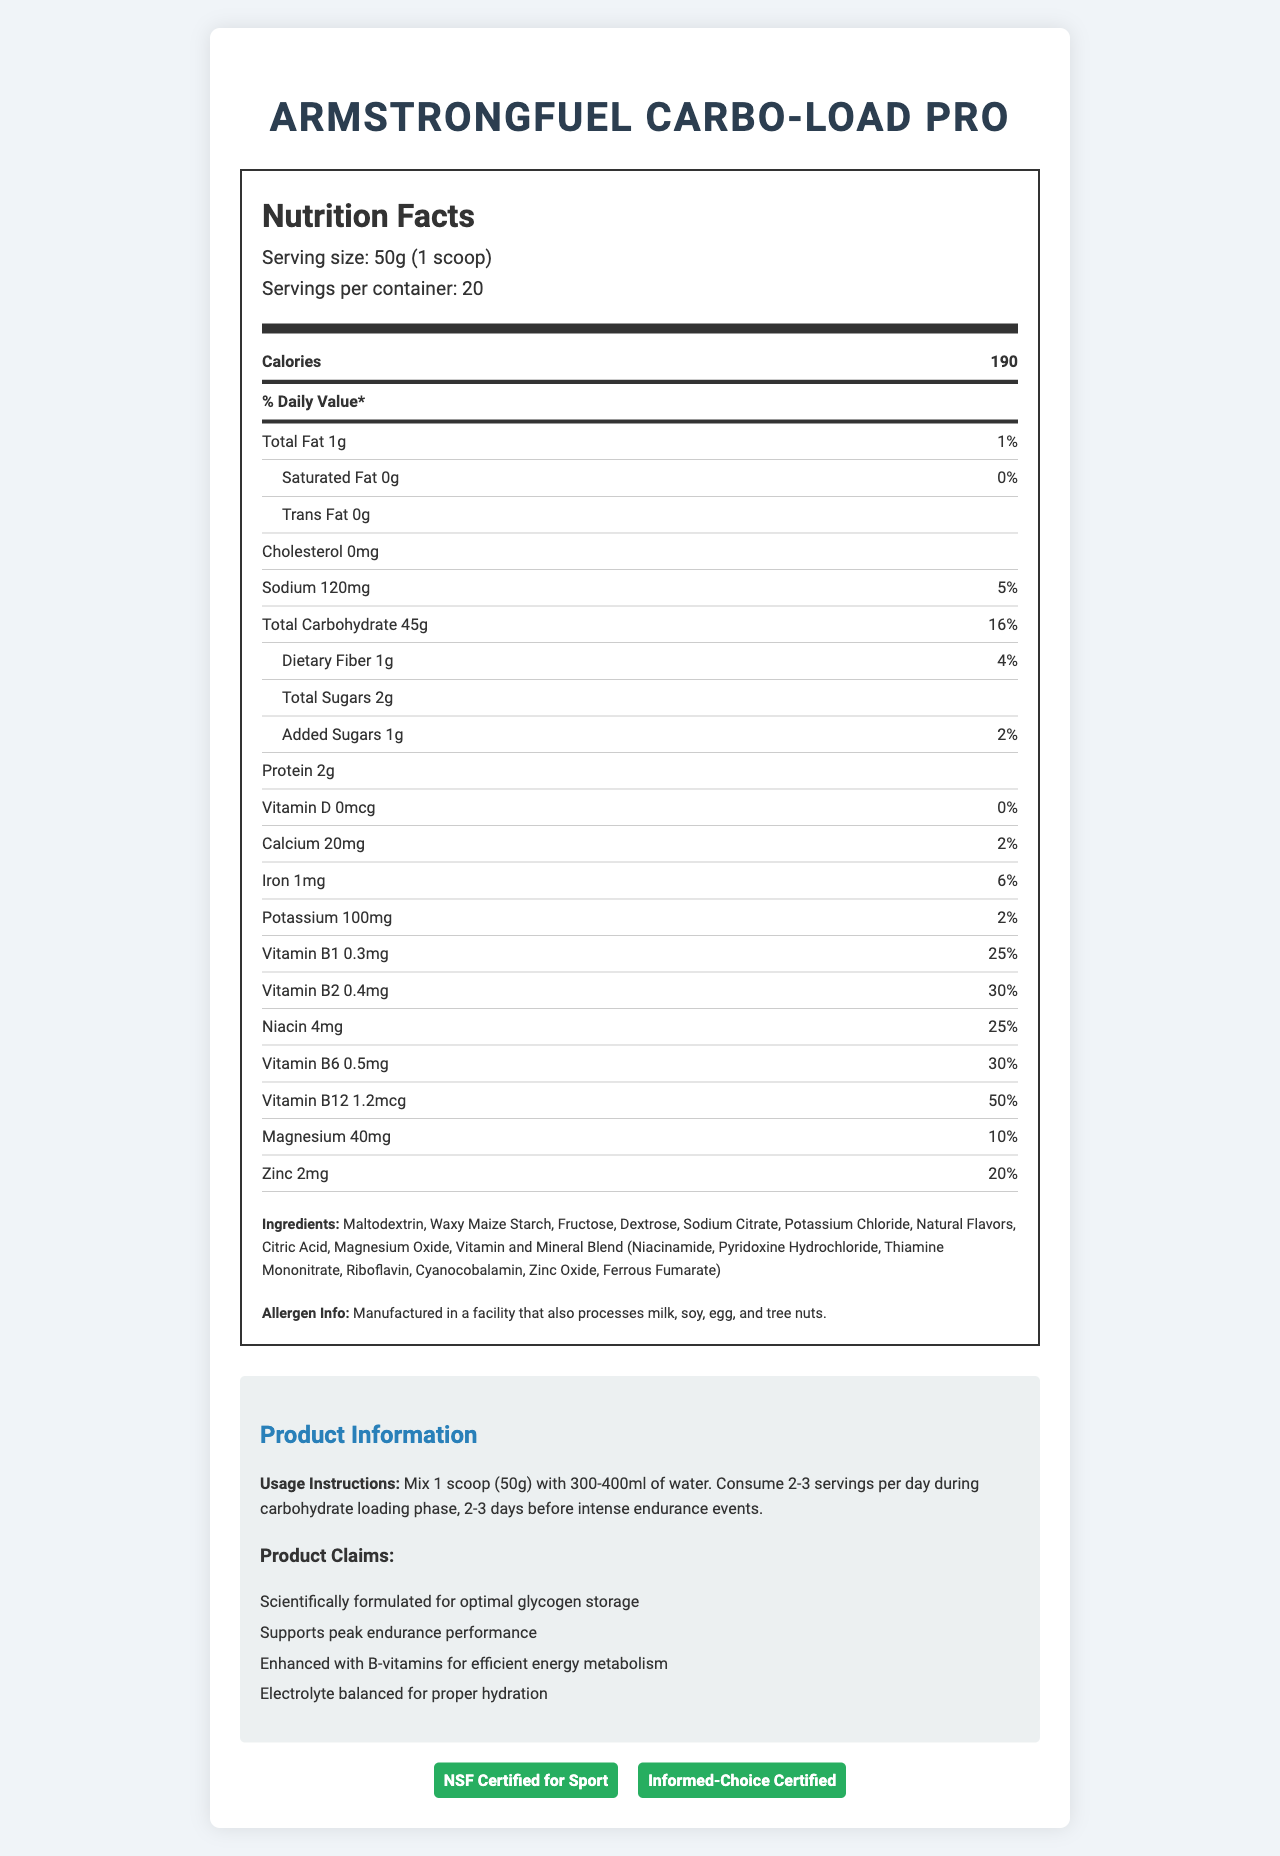what is the serving size for ArmstrongFuel Carbo-Load Pro? The document clearly lists the serving size under the nutrition facts.
Answer: 50g (1 scoop) how many servings are there per container of ArmstrongFuel Carbo-Load Pro? The servings per container information is listed right below the serving size.
Answer: 20 how many calories are there in one serving? The number of calories per serving is listed prominently under the nutrition facts.
Answer: 190 what is the total carbohydrate content per serving? The total carbohydrate content per serving is listed under the nutrition facts with an amount of 45g and a daily value of 16%.
Answer: 45g what are the ingredients listed for ArmstrongFuel Carbo-Load Pro? All the ingredients are listed at the bottom of the nutrition facts section.
Answer: Maltodextrin, Waxy Maize Starch, Fructose, Dextrose, Sodium Citrate, Potassium Chloride, Natural Flavors, Citric Acid, Magnesium Oxide, Vitamin and Mineral Blend (Niacinamide, Pyridoxine Hydrochloride, Thiamine Mononitrate, Riboflavin, Cyanocobalamin, Zinc Oxide, Ferrous Fumarate) How much sodium is in one serving? Sodium is listed in the nutrients section with an amount of 120mg and a daily value of 5%.
Answer: 120mg which vitamins and minerals are provided by this product? A. Vitamin A, Vitamin C B. Vitamin D, Calcium C. Vitamin B1, Vitamin B2, Niacin, Vitamin B6, Vitamin B12, Magnesium, Zinc The document lists Vitamin B1, Vitamin B2, Niacin, Vitamin B6, Vitamin B12, Magnesium, and Zinc with their respective amounts and daily values.
Answer: C what is the daily value percentage for Vitamin B12? A. 25% B. 30% C. 50% D. 100% The daily value percentage for Vitamin B12 is listed as 50%.
Answer: C Is this product certified for sports use? The document mentions that the product is "NSF Certified for Sport" and "Informed-Choice Certified".
Answer: Yes summarize the document's main information. The document intends to inform users about the nutritional content, usage guidelines, and safety certifications of the ArmstrongFuel Carbo-Load Pro supplement.
Answer: The document provides detailed nutrition facts for ArmstrongFuel Carbo-Load Pro, including serving size, calories, macronutrients, vitamins, and minerals. It outlines the ingredients, usage instructions, product claims, allergen information, and certifications. What is the manufacturing facility's allergen information? The allergen information specifies that the product is manufactured in a facility that also processes other common allergens like milk, soy, egg, and tree nuts.
Answer: Manufactured in a facility that also processes milk, soy, egg, and tree nuts. Can this product be used during carbohydrate depletion phases? The document provides usage instructions for carbohydrate loading phases but does not mention carbohydrate depletion phases.
Answer: Not enough information 